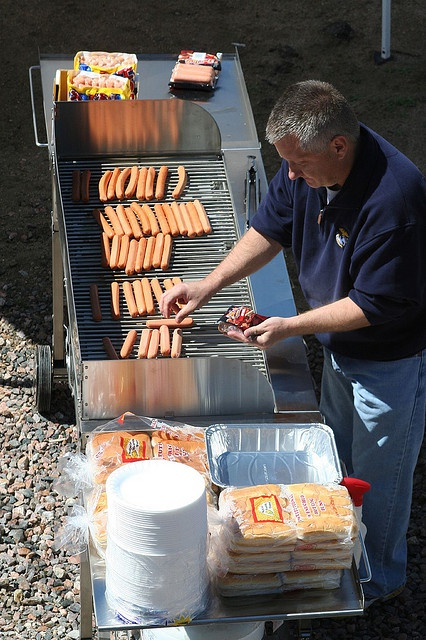Describe the objects in this image and their specific colors. I can see people in black, navy, maroon, and gray tones, hot dog in black and tan tones, bowl in black, white, gray, and darkgray tones, bottle in black, maroon, brown, and gray tones, and hot dog in black, tan, maroon, and salmon tones in this image. 